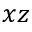<formula> <loc_0><loc_0><loc_500><loc_500>x z</formula> 